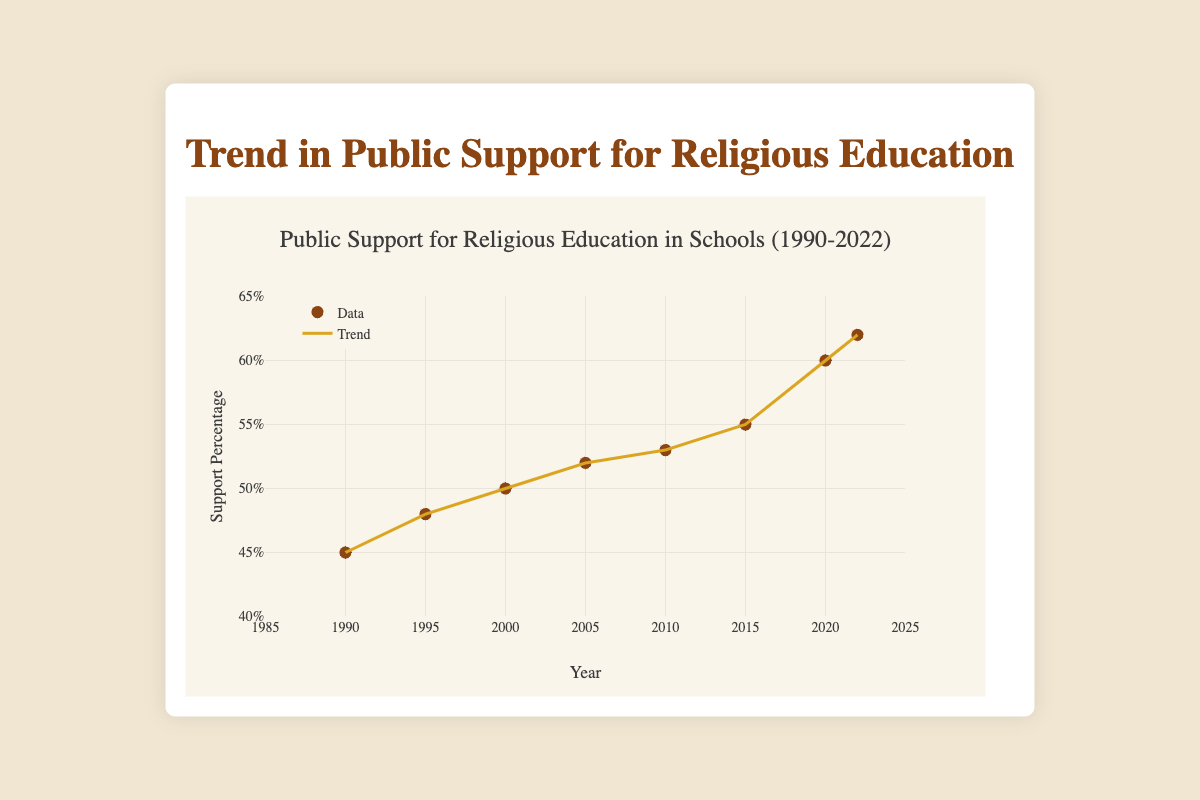What is the title of the chart? The title is located at the top of the figure and acts as a summary of the data presented.
Answer: Public Support for Religious Education in Schools (1990-2022) How many data points are shown in the chart? Count each marker representing public support percentage data on the Scatter Plot.
Answer: 8 What is the general trend in public support for religious education from 1990 to 2022? Observe if the trend line is increasing, decreasing, or steady over the years.
Answer: Increasing Which year shows the highest support percentage for religious education? Look for the highest point on the y-axis and identify the corresponding year on the x-axis.
Answer: 2022 What was the support percentage for religious education in the year 2000? Locate the year 2000 on the x-axis and find the corresponding support percentage value on the y-axis.
Answer: 50% What is the approximate increase in support percentage from 1990 to 2022? Subtract the support percentage in 1990 from that in 2022.
Answer: 17% How does the support percentage for the year 2010 compare with 1995? Identify the support percentages for both years and compare them.
Answer: Higher in 2010 In which year did the public support for religious education reach 55%? Locate the year on the x-axis where the support percentage is 55%.
Answer: 2015 How does the trend line illustrate changes in public support over time? Describe how the trend line connects the data points, showing the progression of public support percentages over the years.
Answer: The trend line shows a consistent increase over time What are the minimum and maximum ranges for the support percentages shown on the y-axis? Examine the y-axis labels to determine the lowest and highest values it displays.
Answer: 40% to 65% 